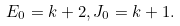Convert formula to latex. <formula><loc_0><loc_0><loc_500><loc_500>E _ { 0 } = k + 2 , J _ { 0 } = k + 1 .</formula> 